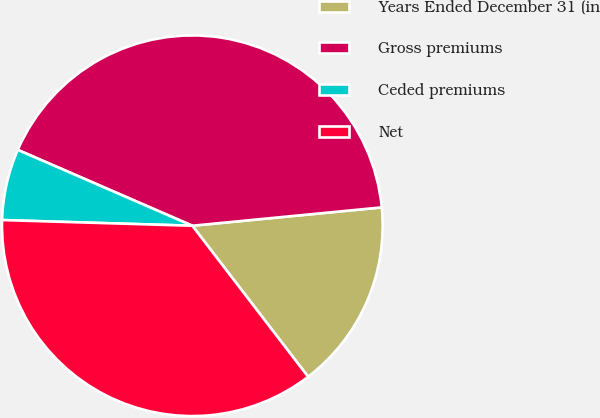Convert chart to OTSL. <chart><loc_0><loc_0><loc_500><loc_500><pie_chart><fcel>Years Ended December 31 (in<fcel>Gross premiums<fcel>Ceded premiums<fcel>Net<nl><fcel>16.13%<fcel>41.94%<fcel>6.05%<fcel>35.89%<nl></chart> 